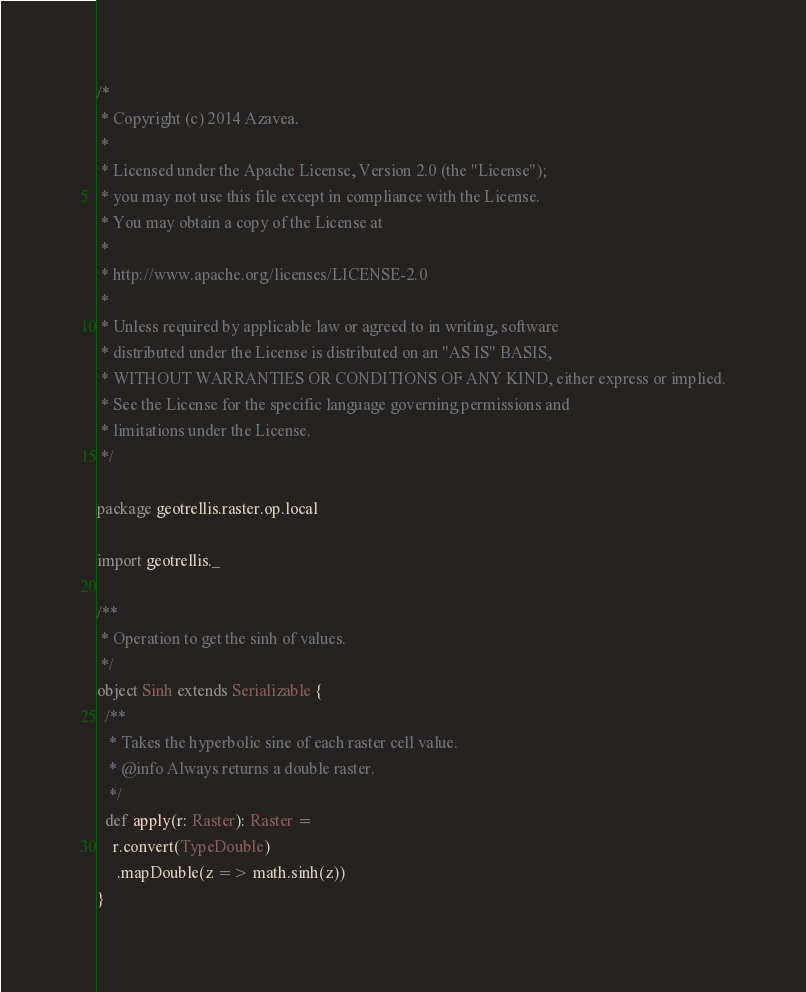Convert code to text. <code><loc_0><loc_0><loc_500><loc_500><_Scala_>/*
 * Copyright (c) 2014 Azavea.
 * 
 * Licensed under the Apache License, Version 2.0 (the "License");
 * you may not use this file except in compliance with the License.
 * You may obtain a copy of the License at
 * 
 * http://www.apache.org/licenses/LICENSE-2.0
 * 
 * Unless required by applicable law or agreed to in writing, software
 * distributed under the License is distributed on an "AS IS" BASIS,
 * WITHOUT WARRANTIES OR CONDITIONS OF ANY KIND, either express or implied.
 * See the License for the specific language governing permissions and
 * limitations under the License.
 */

package geotrellis.raster.op.local

import geotrellis._

/**
 * Operation to get the sinh of values.
 */
object Sinh extends Serializable {
  /**
   * Takes the hyperbolic sine of each raster cell value.
   * @info Always returns a double raster.
   */
  def apply(r: Raster): Raster = 
    r.convert(TypeDouble)
     .mapDouble(z => math.sinh(z))
}
</code> 